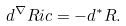<formula> <loc_0><loc_0><loc_500><loc_500>d ^ { \nabla } R i c = - d ^ { \ast } R .</formula> 